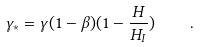<formula> <loc_0><loc_0><loc_500><loc_500>\gamma _ { * } = \gamma ( 1 - \beta ) ( 1 - \frac { H } { H _ { I } } ) \quad .</formula> 